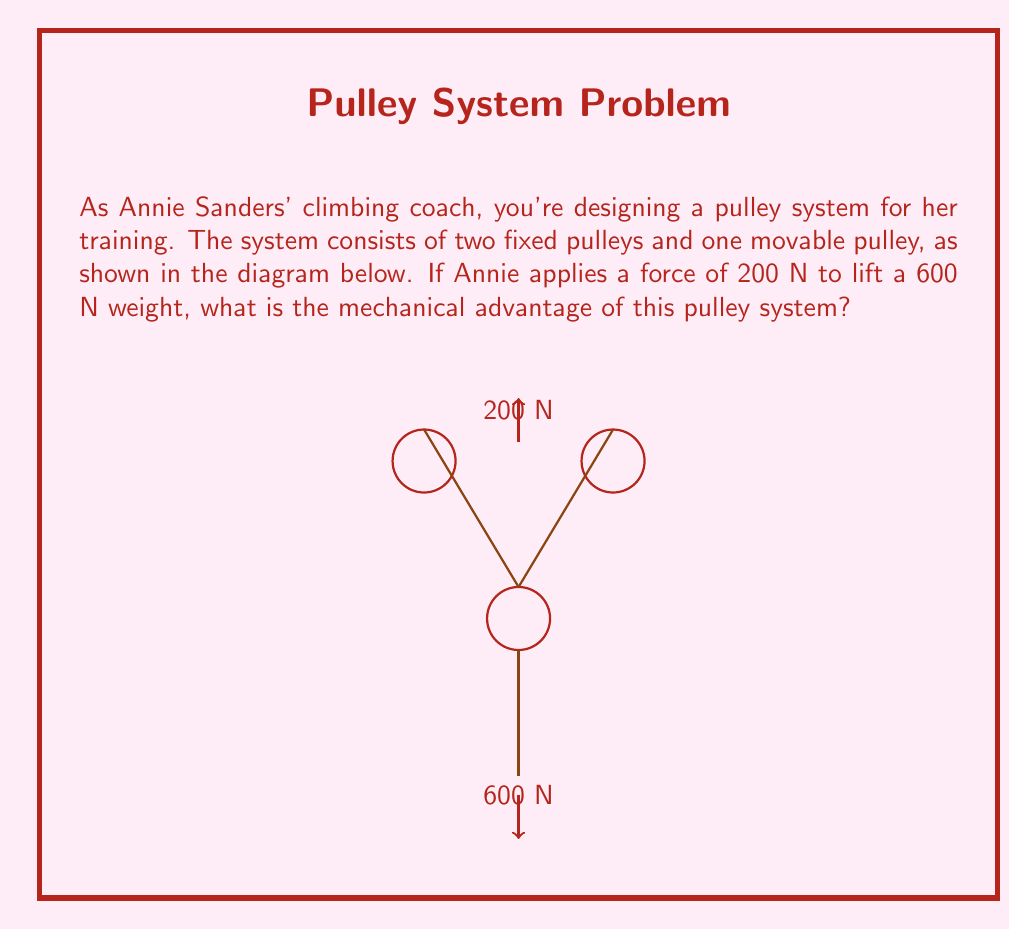Give your solution to this math problem. To calculate the mechanical advantage of this pulley system, we'll follow these steps:

1) First, recall that the mechanical advantage (MA) is defined as:

   $$ MA = \frac{\text{Load}}{\text{Effort}} $$

2) In this system, we have:
   - Load (weight being lifted) = 600 N
   - Effort (force applied by Annie) = 200 N

3) However, we need to consider how the pulley system affects the force distribution:
   - There are three rope segments supporting the movable pulley (and thus the load)
   - Each of these segments bears 1/3 of the total load

4) This means that the actual load on Annie's end of the rope is 1/3 of the total weight:

   $$ \text{Actual Load} = \frac{600 \text{ N}}{3} = 200 \text{ N} $$

5) Now we can calculate the mechanical advantage:

   $$ MA = \frac{\text{Load}}{\text{Effort}} = \frac{600 \text{ N}}{200 \text{ N}} = 3 $$

6) We can verify this result by noting that the number of supporting rope segments (3) matches our calculated mechanical advantage.
Answer: 3 